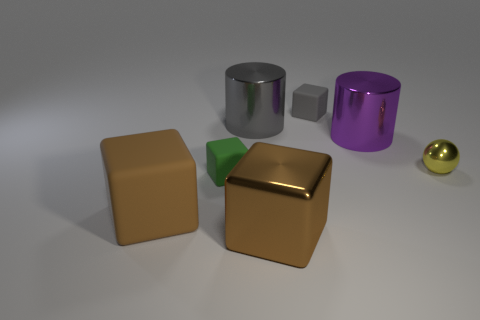Is there anything else that has the same shape as the yellow object?
Offer a terse response. No. What number of big objects are behind the yellow sphere and in front of the large gray thing?
Provide a succinct answer. 1. How many green objects have the same shape as the big brown metallic object?
Your response must be concise. 1. Is the material of the yellow thing the same as the green cube?
Offer a very short reply. No. The purple shiny thing behind the tiny thing in front of the tiny sphere is what shape?
Make the answer very short. Cylinder. How many purple cylinders are on the left side of the tiny block that is to the right of the tiny green matte cube?
Your answer should be very brief. 0. There is a object that is to the right of the large gray shiny object and left of the tiny gray object; what is its material?
Your response must be concise. Metal. The green rubber object that is the same size as the gray cube is what shape?
Give a very brief answer. Cube. What is the color of the rubber cube right of the big brown cube that is right of the brown rubber object that is in front of the gray cylinder?
Provide a succinct answer. Gray. What number of things are either brown objects that are in front of the brown matte thing or tiny balls?
Offer a terse response. 2. 